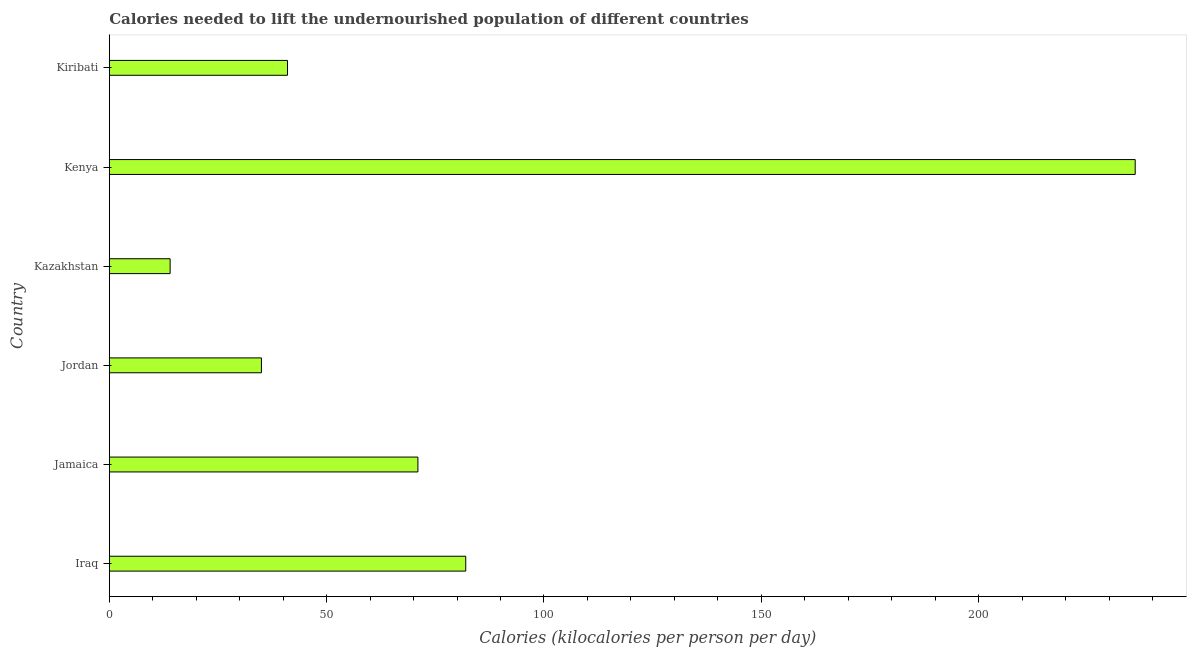Does the graph contain grids?
Your answer should be compact. No. What is the title of the graph?
Keep it short and to the point. Calories needed to lift the undernourished population of different countries. What is the label or title of the X-axis?
Keep it short and to the point. Calories (kilocalories per person per day). What is the depth of food deficit in Iraq?
Offer a very short reply. 82. Across all countries, what is the maximum depth of food deficit?
Your answer should be compact. 236. Across all countries, what is the minimum depth of food deficit?
Your response must be concise. 14. In which country was the depth of food deficit maximum?
Your answer should be very brief. Kenya. In which country was the depth of food deficit minimum?
Keep it short and to the point. Kazakhstan. What is the sum of the depth of food deficit?
Provide a succinct answer. 479. What is the difference between the depth of food deficit in Kazakhstan and Kenya?
Your response must be concise. -222. What is the average depth of food deficit per country?
Offer a terse response. 79.83. What is the median depth of food deficit?
Offer a terse response. 56. What is the ratio of the depth of food deficit in Jamaica to that in Kazakhstan?
Your response must be concise. 5.07. Is the difference between the depth of food deficit in Jordan and Kazakhstan greater than the difference between any two countries?
Keep it short and to the point. No. What is the difference between the highest and the second highest depth of food deficit?
Give a very brief answer. 154. Is the sum of the depth of food deficit in Jamaica and Jordan greater than the maximum depth of food deficit across all countries?
Offer a very short reply. No. What is the difference between the highest and the lowest depth of food deficit?
Your response must be concise. 222. In how many countries, is the depth of food deficit greater than the average depth of food deficit taken over all countries?
Offer a terse response. 2. How many bars are there?
Provide a succinct answer. 6. Are all the bars in the graph horizontal?
Provide a succinct answer. Yes. What is the difference between two consecutive major ticks on the X-axis?
Your response must be concise. 50. What is the Calories (kilocalories per person per day) of Jordan?
Make the answer very short. 35. What is the Calories (kilocalories per person per day) of Kenya?
Offer a very short reply. 236. What is the Calories (kilocalories per person per day) in Kiribati?
Ensure brevity in your answer.  41. What is the difference between the Calories (kilocalories per person per day) in Iraq and Jamaica?
Provide a short and direct response. 11. What is the difference between the Calories (kilocalories per person per day) in Iraq and Kenya?
Offer a very short reply. -154. What is the difference between the Calories (kilocalories per person per day) in Iraq and Kiribati?
Offer a terse response. 41. What is the difference between the Calories (kilocalories per person per day) in Jamaica and Kenya?
Your answer should be compact. -165. What is the difference between the Calories (kilocalories per person per day) in Jamaica and Kiribati?
Offer a very short reply. 30. What is the difference between the Calories (kilocalories per person per day) in Jordan and Kenya?
Ensure brevity in your answer.  -201. What is the difference between the Calories (kilocalories per person per day) in Kazakhstan and Kenya?
Your response must be concise. -222. What is the difference between the Calories (kilocalories per person per day) in Kenya and Kiribati?
Provide a short and direct response. 195. What is the ratio of the Calories (kilocalories per person per day) in Iraq to that in Jamaica?
Your response must be concise. 1.16. What is the ratio of the Calories (kilocalories per person per day) in Iraq to that in Jordan?
Give a very brief answer. 2.34. What is the ratio of the Calories (kilocalories per person per day) in Iraq to that in Kazakhstan?
Ensure brevity in your answer.  5.86. What is the ratio of the Calories (kilocalories per person per day) in Iraq to that in Kenya?
Provide a short and direct response. 0.35. What is the ratio of the Calories (kilocalories per person per day) in Iraq to that in Kiribati?
Provide a succinct answer. 2. What is the ratio of the Calories (kilocalories per person per day) in Jamaica to that in Jordan?
Your response must be concise. 2.03. What is the ratio of the Calories (kilocalories per person per day) in Jamaica to that in Kazakhstan?
Offer a terse response. 5.07. What is the ratio of the Calories (kilocalories per person per day) in Jamaica to that in Kenya?
Your response must be concise. 0.3. What is the ratio of the Calories (kilocalories per person per day) in Jamaica to that in Kiribati?
Offer a terse response. 1.73. What is the ratio of the Calories (kilocalories per person per day) in Jordan to that in Kazakhstan?
Ensure brevity in your answer.  2.5. What is the ratio of the Calories (kilocalories per person per day) in Jordan to that in Kenya?
Make the answer very short. 0.15. What is the ratio of the Calories (kilocalories per person per day) in Jordan to that in Kiribati?
Your answer should be very brief. 0.85. What is the ratio of the Calories (kilocalories per person per day) in Kazakhstan to that in Kenya?
Your response must be concise. 0.06. What is the ratio of the Calories (kilocalories per person per day) in Kazakhstan to that in Kiribati?
Give a very brief answer. 0.34. What is the ratio of the Calories (kilocalories per person per day) in Kenya to that in Kiribati?
Your answer should be compact. 5.76. 